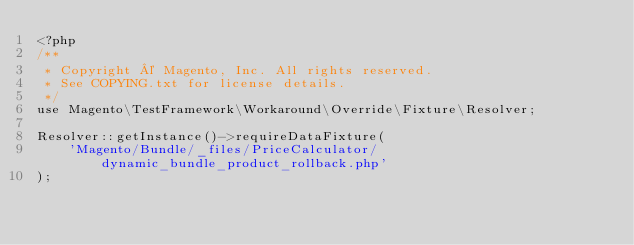<code> <loc_0><loc_0><loc_500><loc_500><_PHP_><?php
/**
 * Copyright © Magento, Inc. All rights reserved.
 * See COPYING.txt for license details.
 */
use Magento\TestFramework\Workaround\Override\Fixture\Resolver;

Resolver::getInstance()->requireDataFixture(
    'Magento/Bundle/_files/PriceCalculator/dynamic_bundle_product_rollback.php'
);
</code> 